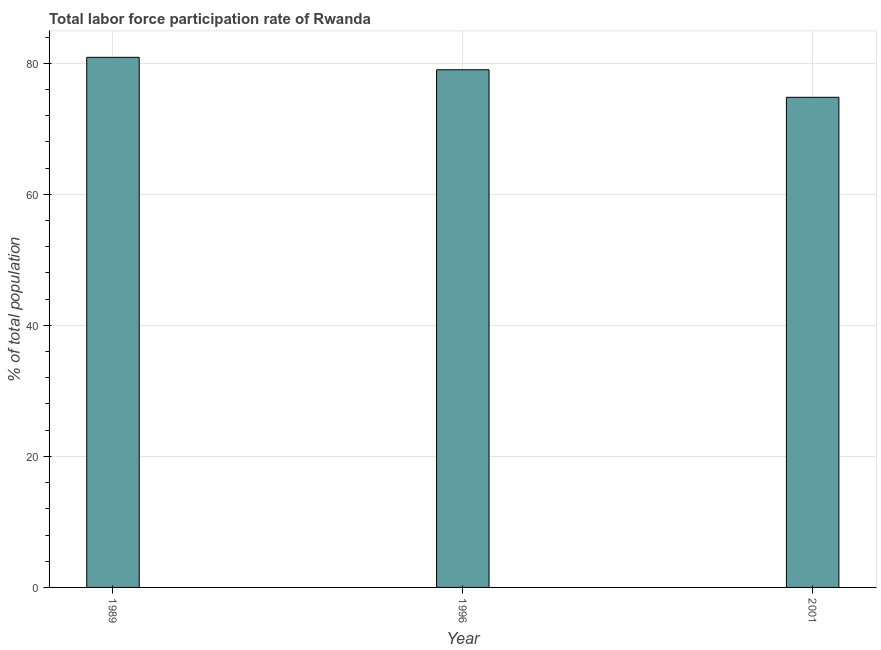Does the graph contain grids?
Your answer should be very brief. Yes. What is the title of the graph?
Your answer should be compact. Total labor force participation rate of Rwanda. What is the label or title of the X-axis?
Make the answer very short. Year. What is the label or title of the Y-axis?
Keep it short and to the point. % of total population. What is the total labor force participation rate in 1996?
Your response must be concise. 79. Across all years, what is the maximum total labor force participation rate?
Provide a short and direct response. 80.9. Across all years, what is the minimum total labor force participation rate?
Offer a very short reply. 74.8. In which year was the total labor force participation rate maximum?
Offer a very short reply. 1989. In which year was the total labor force participation rate minimum?
Provide a succinct answer. 2001. What is the sum of the total labor force participation rate?
Your response must be concise. 234.7. What is the average total labor force participation rate per year?
Your response must be concise. 78.23. What is the median total labor force participation rate?
Provide a succinct answer. 79. Do a majority of the years between 2001 and 1989 (inclusive) have total labor force participation rate greater than 12 %?
Keep it short and to the point. Yes. What is the ratio of the total labor force participation rate in 1989 to that in 1996?
Offer a very short reply. 1.02. Is the difference between the total labor force participation rate in 1989 and 1996 greater than the difference between any two years?
Keep it short and to the point. No. What is the difference between the highest and the second highest total labor force participation rate?
Provide a succinct answer. 1.9. What is the difference between the highest and the lowest total labor force participation rate?
Offer a very short reply. 6.1. Are all the bars in the graph horizontal?
Your response must be concise. No. How many years are there in the graph?
Make the answer very short. 3. What is the difference between two consecutive major ticks on the Y-axis?
Make the answer very short. 20. What is the % of total population of 1989?
Make the answer very short. 80.9. What is the % of total population in 1996?
Your answer should be compact. 79. What is the % of total population of 2001?
Offer a terse response. 74.8. What is the difference between the % of total population in 1989 and 1996?
Provide a succinct answer. 1.9. What is the difference between the % of total population in 1989 and 2001?
Your answer should be very brief. 6.1. What is the ratio of the % of total population in 1989 to that in 1996?
Your answer should be very brief. 1.02. What is the ratio of the % of total population in 1989 to that in 2001?
Your answer should be very brief. 1.08. What is the ratio of the % of total population in 1996 to that in 2001?
Provide a succinct answer. 1.06. 